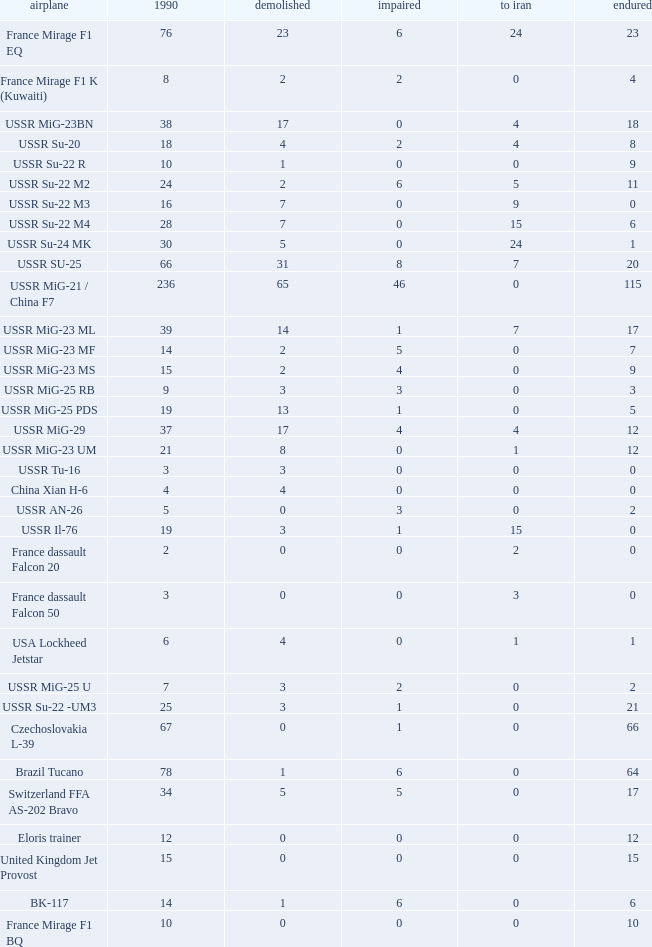0, what was the number in 1990? 1.0. Could you help me parse every detail presented in this table? {'header': ['airplane', '1990', 'demolished', 'impaired', 'to iran', 'endured'], 'rows': [['France Mirage F1 EQ', '76', '23', '6', '24', '23'], ['France Mirage F1 K (Kuwaiti)', '8', '2', '2', '0', '4'], ['USSR MiG-23BN', '38', '17', '0', '4', '18'], ['USSR Su-20', '18', '4', '2', '4', '8'], ['USSR Su-22 R', '10', '1', '0', '0', '9'], ['USSR Su-22 M2', '24', '2', '6', '5', '11'], ['USSR Su-22 M3', '16', '7', '0', '9', '0'], ['USSR Su-22 M4', '28', '7', '0', '15', '6'], ['USSR Su-24 MK', '30', '5', '0', '24', '1'], ['USSR SU-25', '66', '31', '8', '7', '20'], ['USSR MiG-21 / China F7', '236', '65', '46', '0', '115'], ['USSR MiG-23 ML', '39', '14', '1', '7', '17'], ['USSR MiG-23 MF', '14', '2', '5', '0', '7'], ['USSR MiG-23 MS', '15', '2', '4', '0', '9'], ['USSR MiG-25 RB', '9', '3', '3', '0', '3'], ['USSR MiG-25 PDS', '19', '13', '1', '0', '5'], ['USSR MiG-29', '37', '17', '4', '4', '12'], ['USSR MiG-23 UM', '21', '8', '0', '1', '12'], ['USSR Tu-16', '3', '3', '0', '0', '0'], ['China Xian H-6', '4', '4', '0', '0', '0'], ['USSR AN-26', '5', '0', '3', '0', '2'], ['USSR Il-76', '19', '3', '1', '15', '0'], ['France dassault Falcon 20', '2', '0', '0', '2', '0'], ['France dassault Falcon 50', '3', '0', '0', '3', '0'], ['USA Lockheed Jetstar', '6', '4', '0', '1', '1'], ['USSR MiG-25 U', '7', '3', '2', '0', '2'], ['USSR Su-22 -UM3', '25', '3', '1', '0', '21'], ['Czechoslovakia L-39', '67', '0', '1', '0', '66'], ['Brazil Tucano', '78', '1', '6', '0', '64'], ['Switzerland FFA AS-202 Bravo', '34', '5', '5', '0', '17'], ['Eloris trainer', '12', '0', '0', '0', '12'], ['United Kingdom Jet Provost', '15', '0', '0', '0', '15'], ['BK-117', '14', '1', '6', '0', '6'], ['France Mirage F1 BQ', '10', '0', '0', '0', '10']]} 